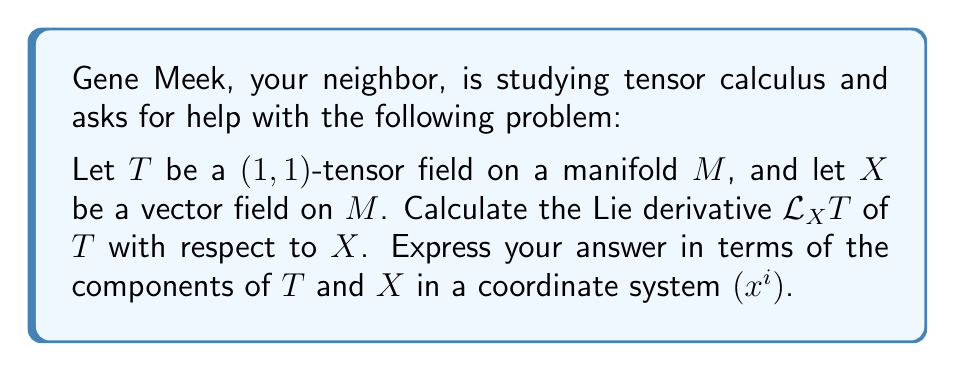Solve this math problem. To solve this problem, we'll follow these steps:

1) Recall the formula for the Lie derivative of a $(1,1)$-tensor field $T$ with respect to a vector field $X$:

   $$(\mathcal{L}_X T)^i_j = X^k \partial_k T^i_j - T^k_j \partial_k X^i + T^i_k \partial_j X^k$$

2) Let's break down each term:
   
   a) $X^k \partial_k T^i_j$ represents the directional derivative of $T$ along $X$.
   
   b) $-T^k_j \partial_k X^i$ accounts for the change in the contravariant component of $T$.
   
   c) $T^i_k \partial_j X^k$ accounts for the change in the covariant component of $T$.

3) This formula gives us the components of the Lie derivative in the chosen coordinate system $(x^i)$.

4) The result is another $(1,1)$-tensor field, as the Lie derivative preserves the tensor type.

5) Note that $\partial_k = \frac{\partial}{\partial x^k}$ is the partial derivative with respect to the $k$-th coordinate.

This formula encapsulates how the tensor field $T$ changes along the flow of the vector field $X$, taking into account both the change in $T$ itself and how $X$ affects the coordinate system.
Answer: $$(\mathcal{L}_X T)^i_j = X^k \partial_k T^i_j - T^k_j \partial_k X^i + T^i_k \partial_j X^k$$ 